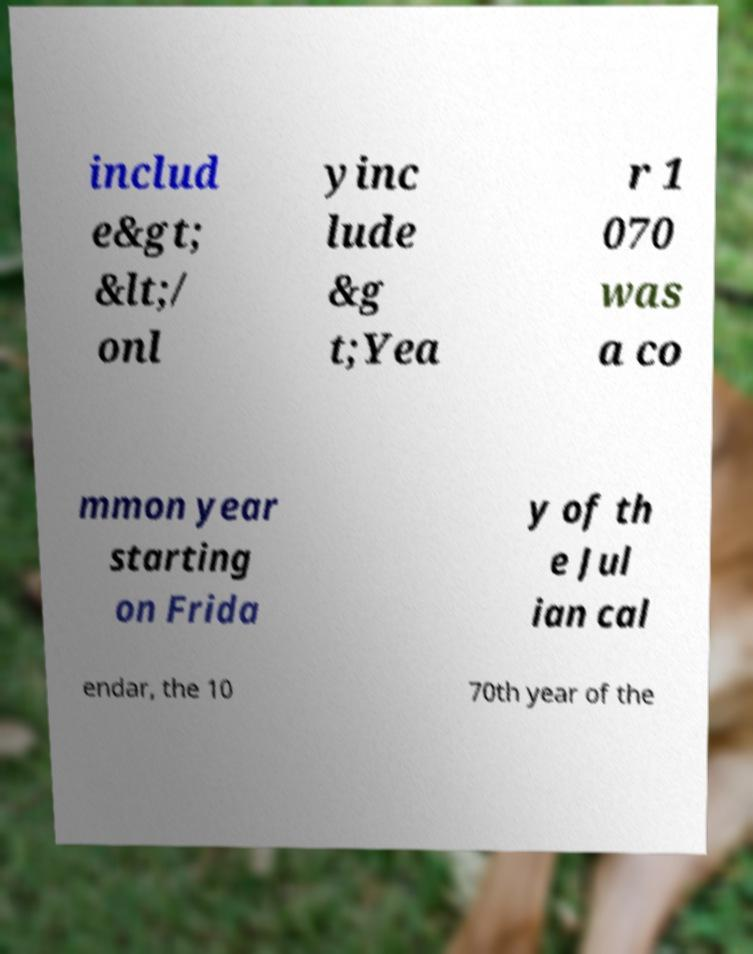Could you assist in decoding the text presented in this image and type it out clearly? includ e&gt; &lt;/ onl yinc lude &g t;Yea r 1 070 was a co mmon year starting on Frida y of th e Jul ian cal endar, the 10 70th year of the 